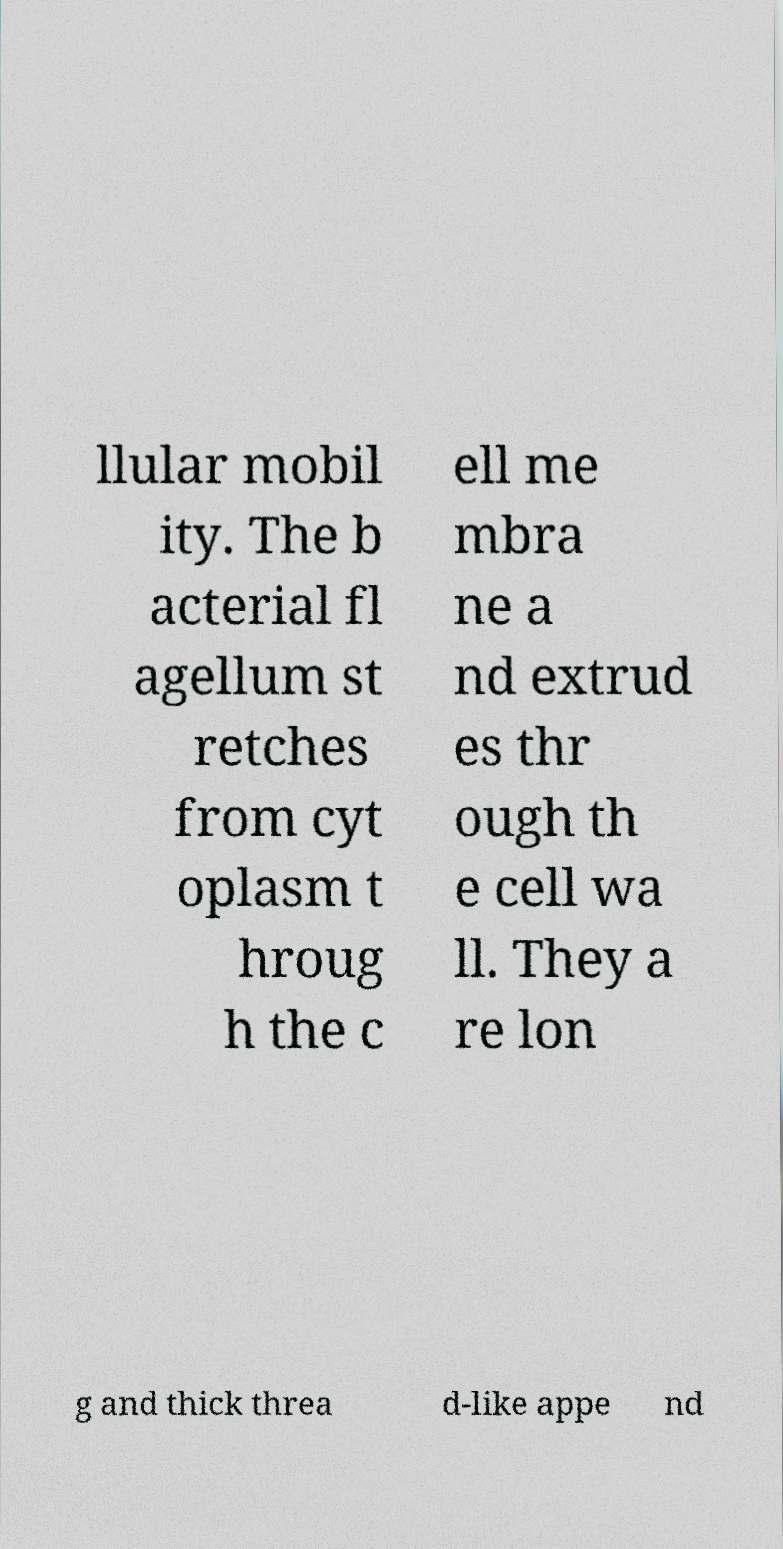For documentation purposes, I need the text within this image transcribed. Could you provide that? llular mobil ity. The b acterial fl agellum st retches from cyt oplasm t hroug h the c ell me mbra ne a nd extrud es thr ough th e cell wa ll. They a re lon g and thick threa d-like appe nd 